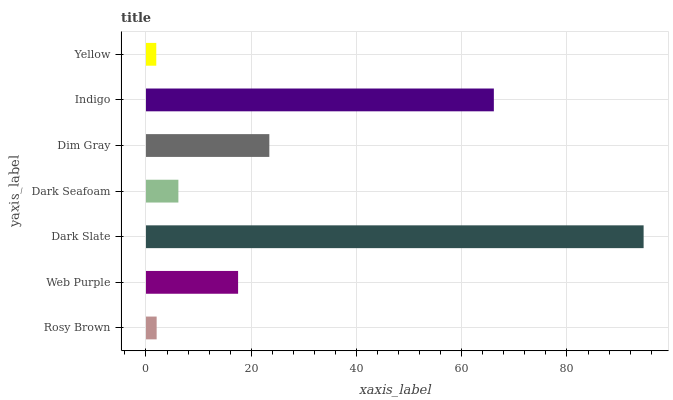Is Yellow the minimum?
Answer yes or no. Yes. Is Dark Slate the maximum?
Answer yes or no. Yes. Is Web Purple the minimum?
Answer yes or no. No. Is Web Purple the maximum?
Answer yes or no. No. Is Web Purple greater than Rosy Brown?
Answer yes or no. Yes. Is Rosy Brown less than Web Purple?
Answer yes or no. Yes. Is Rosy Brown greater than Web Purple?
Answer yes or no. No. Is Web Purple less than Rosy Brown?
Answer yes or no. No. Is Web Purple the high median?
Answer yes or no. Yes. Is Web Purple the low median?
Answer yes or no. Yes. Is Dim Gray the high median?
Answer yes or no. No. Is Rosy Brown the low median?
Answer yes or no. No. 